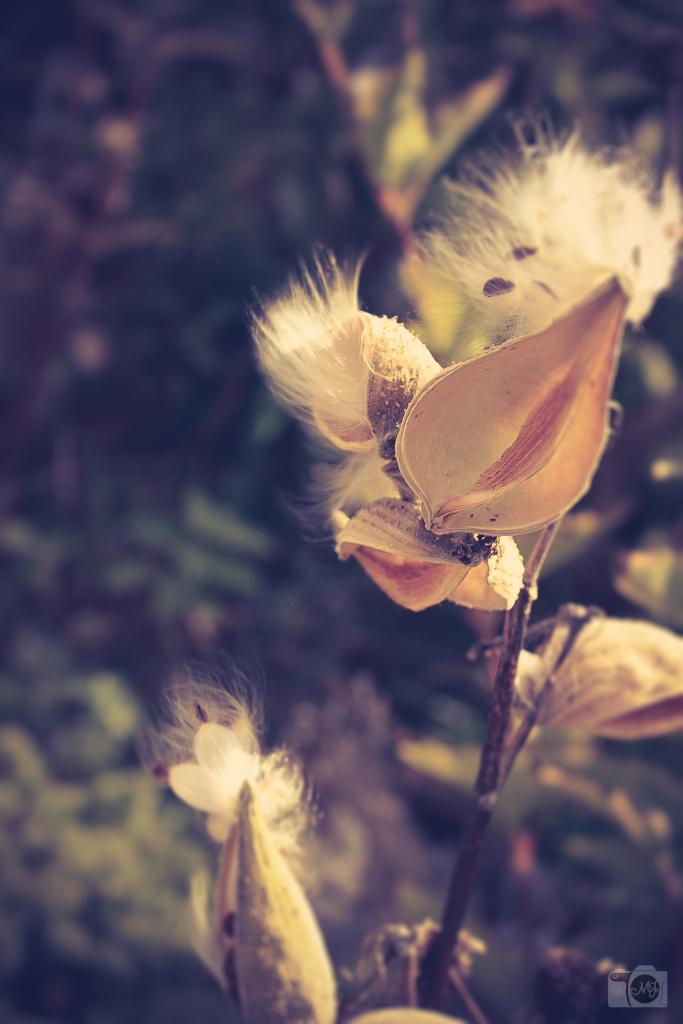What is the main subject in the center of the image? There is a plant in the center of the image. What additional features can be seen in the image? There are flowers in the image. What type of button can be seen on the plant in the image? There is no button present on the plant in the image. How many times does the plant sneeze in the image? Plants do not have the ability to sneeze, so this action cannot be observed in the image. 